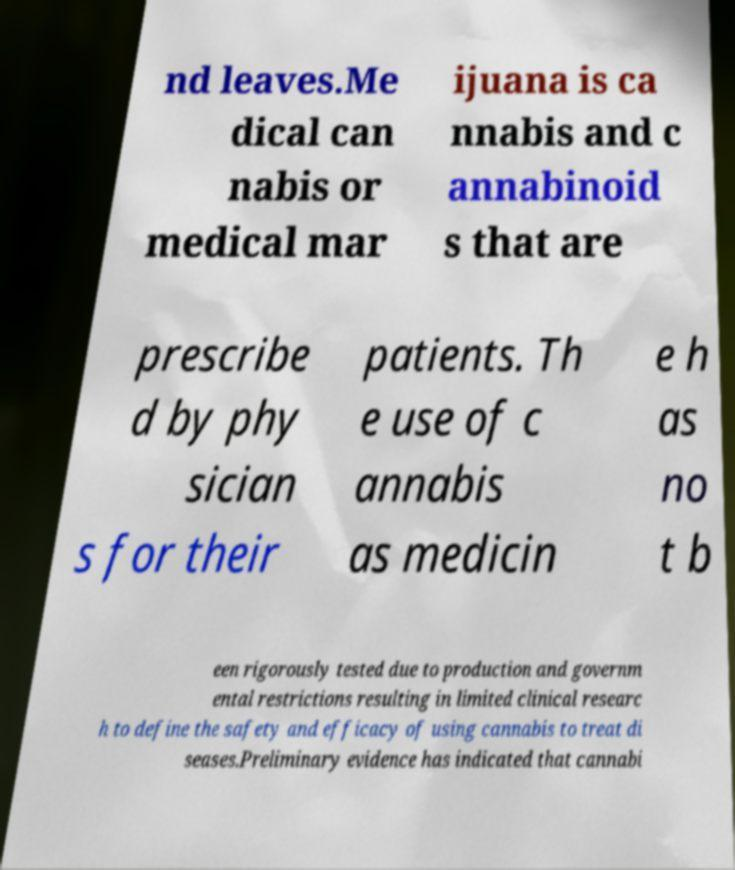Please identify and transcribe the text found in this image. nd leaves.Me dical can nabis or medical mar ijuana is ca nnabis and c annabinoid s that are prescribe d by phy sician s for their patients. Th e use of c annabis as medicin e h as no t b een rigorously tested due to production and governm ental restrictions resulting in limited clinical researc h to define the safety and efficacy of using cannabis to treat di seases.Preliminary evidence has indicated that cannabi 